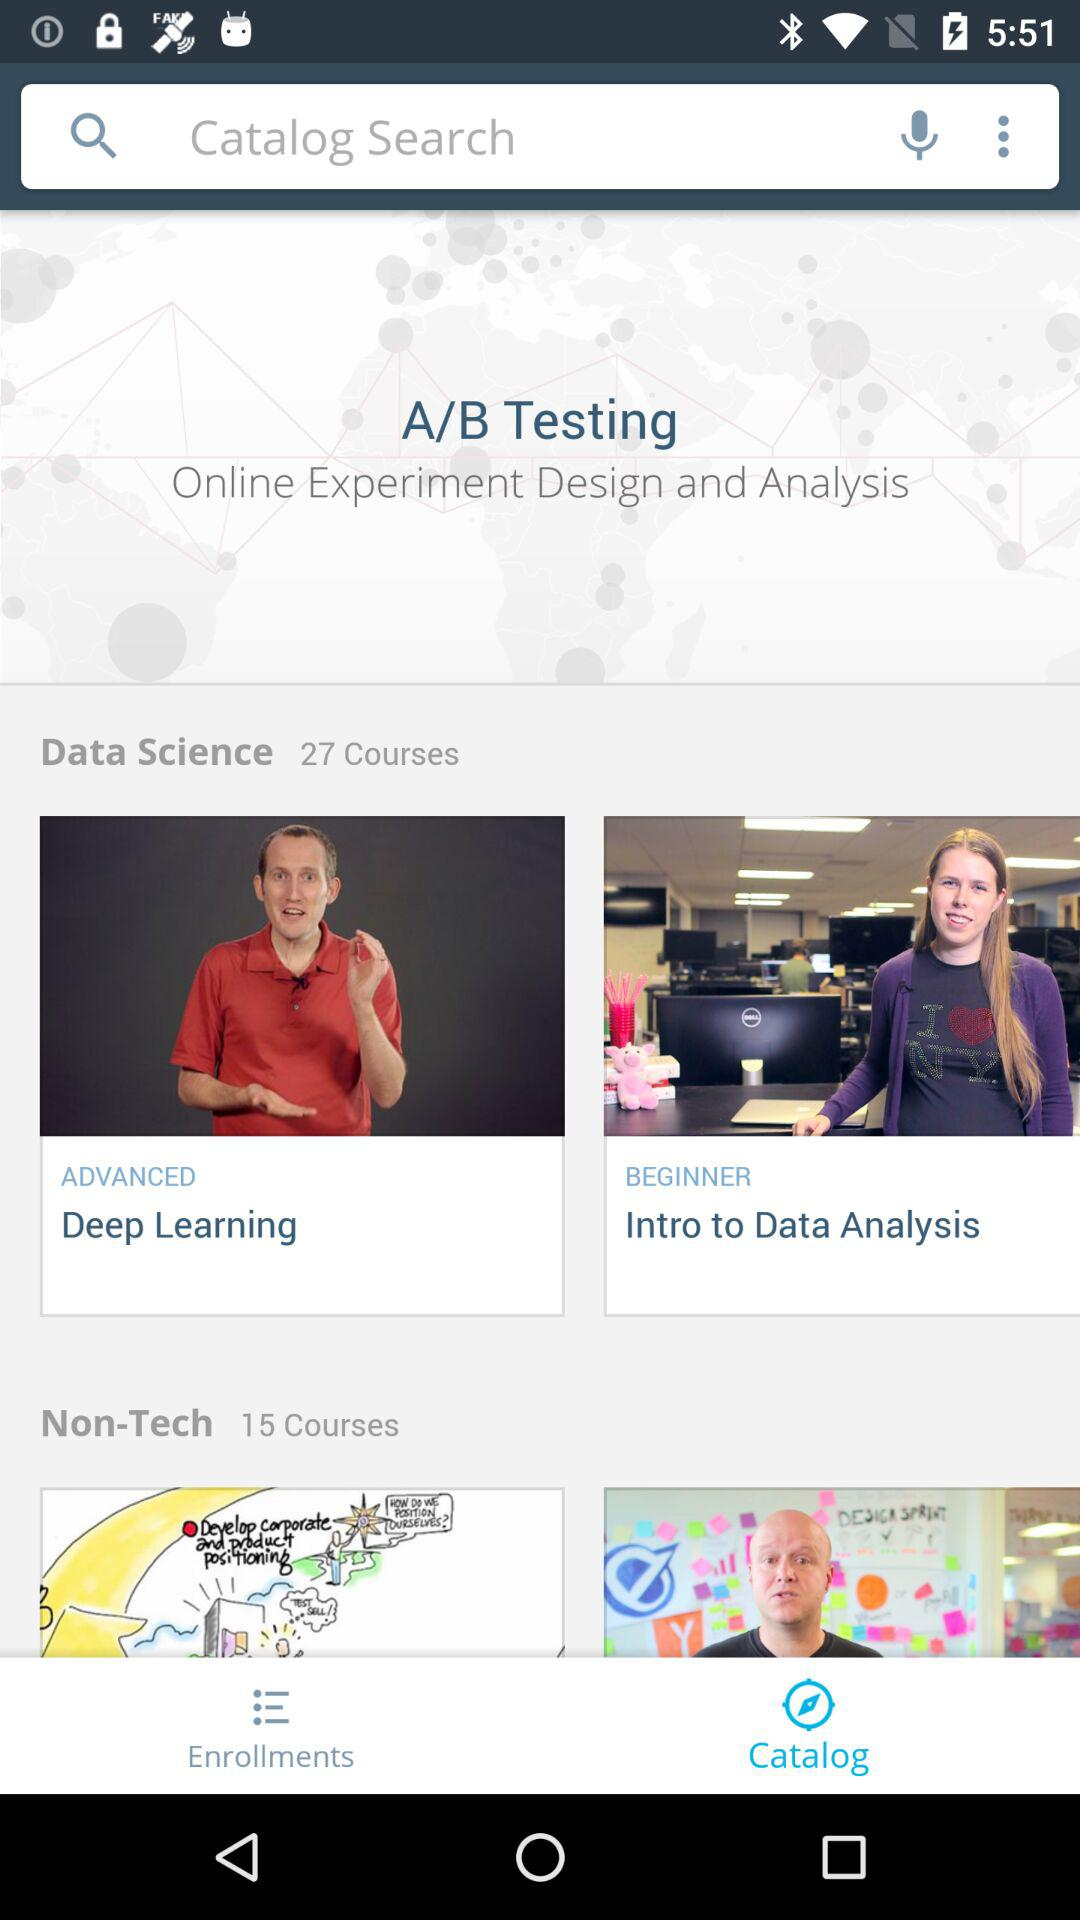Which tab has been selected? The tab that has been selected is "Catalog". 